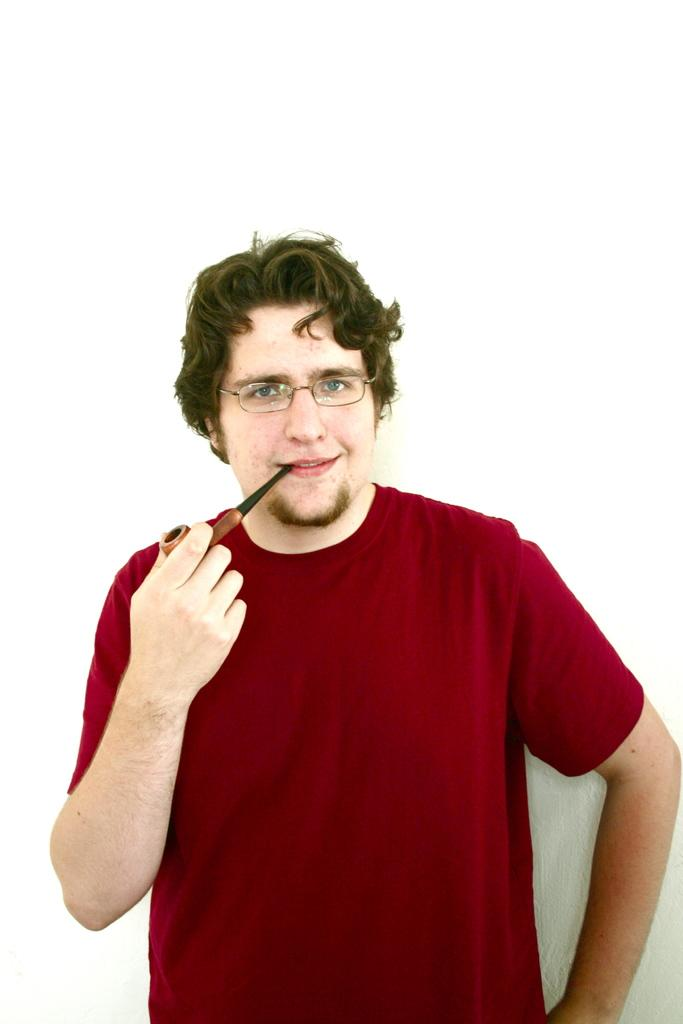What is the main subject of the image? There is a person standing in the center of the image. Can you describe the person's appearance? The person is wearing glasses. What is the person holding in the image? The person is holding an object. What can be seen in the background of the image? There is a wall in the background of the image. What type of root can be seen growing on the sofa in the image? There is no sofa or root present in the image. What event is taking place in the image? The image does not depict any specific event; it simply shows a person standing and holding an object. 